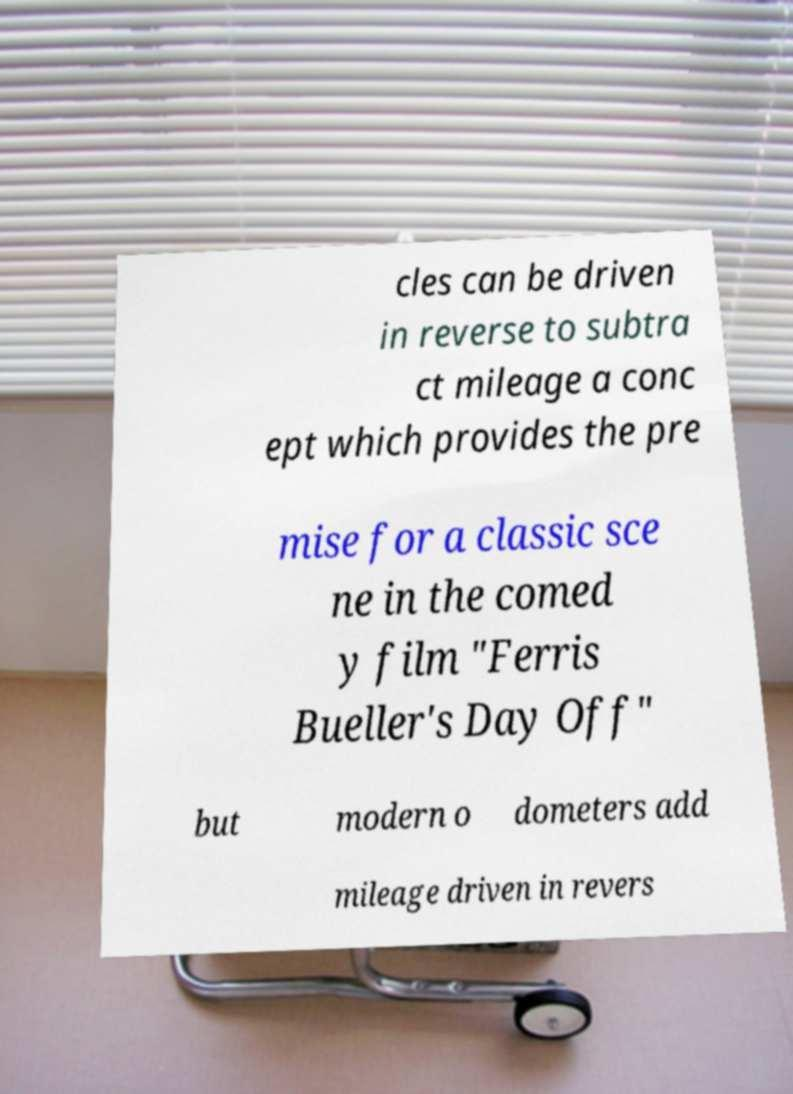Could you assist in decoding the text presented in this image and type it out clearly? cles can be driven in reverse to subtra ct mileage a conc ept which provides the pre mise for a classic sce ne in the comed y film "Ferris Bueller's Day Off" but modern o dometers add mileage driven in revers 